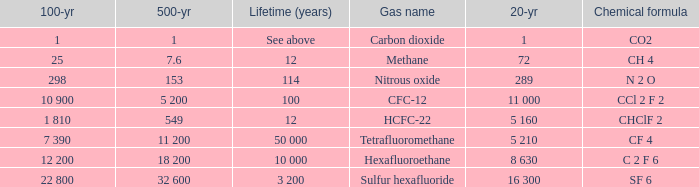What is the lifetime (years) for chemical formula ch 4? 12.0. 